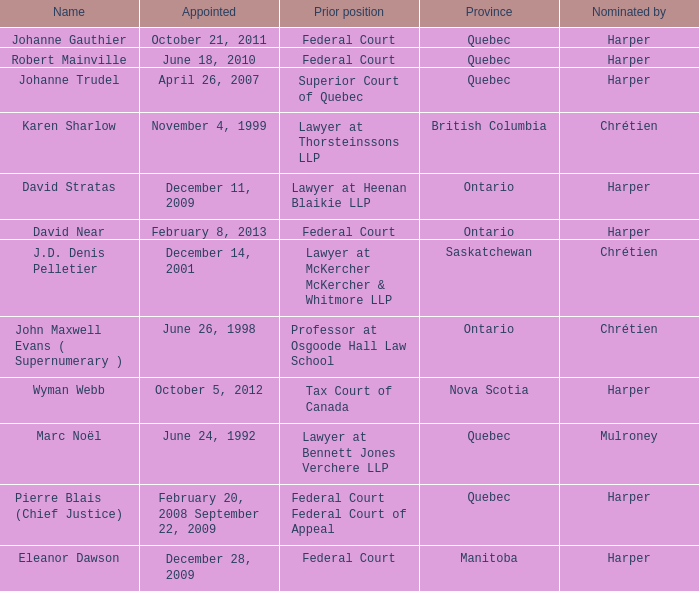What was the prior position held by Wyman Webb? Tax Court of Canada. Would you mind parsing the complete table? {'header': ['Name', 'Appointed', 'Prior position', 'Province', 'Nominated by'], 'rows': [['Johanne Gauthier', 'October 21, 2011', 'Federal Court', 'Quebec', 'Harper'], ['Robert Mainville', 'June 18, 2010', 'Federal Court', 'Quebec', 'Harper'], ['Johanne Trudel', 'April 26, 2007', 'Superior Court of Quebec', 'Quebec', 'Harper'], ['Karen Sharlow', 'November 4, 1999', 'Lawyer at Thorsteinssons LLP', 'British Columbia', 'Chrétien'], ['David Stratas', 'December 11, 2009', 'Lawyer at Heenan Blaikie LLP', 'Ontario', 'Harper'], ['David Near', 'February 8, 2013', 'Federal Court', 'Ontario', 'Harper'], ['J.D. Denis Pelletier', 'December 14, 2001', 'Lawyer at McKercher McKercher & Whitmore LLP', 'Saskatchewan', 'Chrétien'], ['John Maxwell Evans ( Supernumerary )', 'June 26, 1998', 'Professor at Osgoode Hall Law School', 'Ontario', 'Chrétien'], ['Wyman Webb', 'October 5, 2012', 'Tax Court of Canada', 'Nova Scotia', 'Harper'], ['Marc Noël', 'June 24, 1992', 'Lawyer at Bennett Jones Verchere LLP', 'Quebec', 'Mulroney'], ['Pierre Blais (Chief Justice)', 'February 20, 2008 September 22, 2009', 'Federal Court Federal Court of Appeal', 'Quebec', 'Harper'], ['Eleanor Dawson', 'December 28, 2009', 'Federal Court', 'Manitoba', 'Harper']]} 